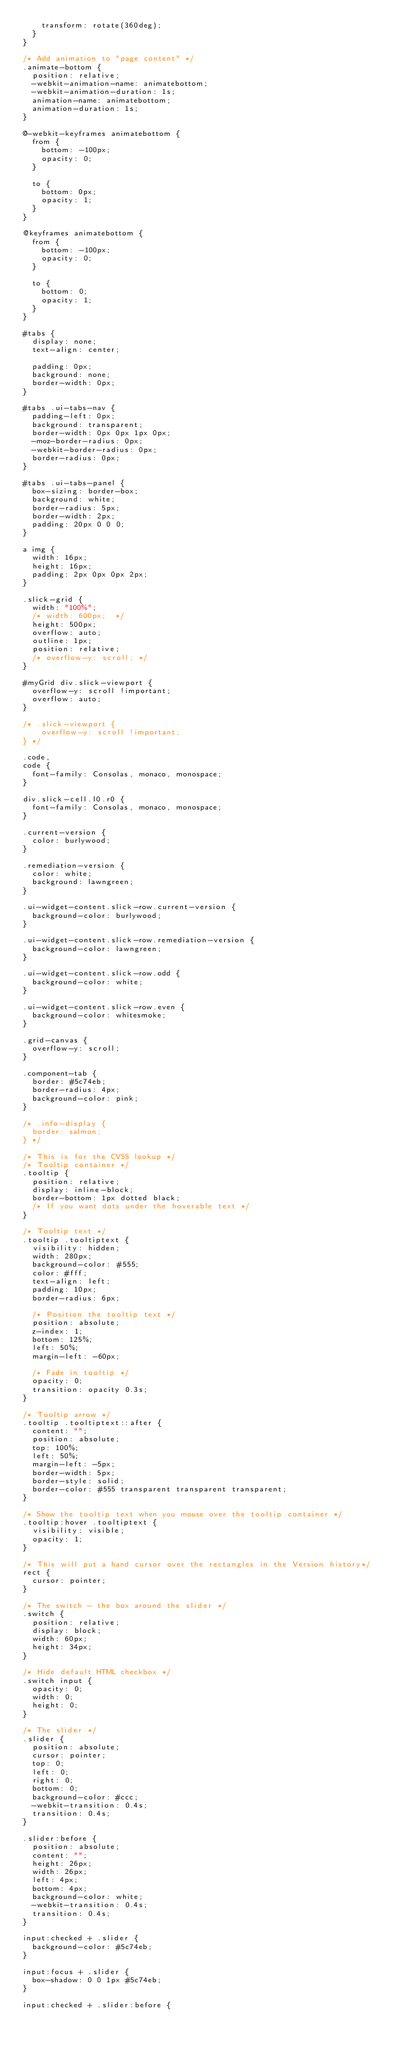<code> <loc_0><loc_0><loc_500><loc_500><_CSS_>    transform: rotate(360deg);
  }
}

/* Add animation to "page content" */
.animate-bottom {
  position: relative;
  -webkit-animation-name: animatebottom;
  -webkit-animation-duration: 1s;
  animation-name: animatebottom;
  animation-duration: 1s;
}

@-webkit-keyframes animatebottom {
  from {
    bottom: -100px;
    opacity: 0;
  }

  to {
    bottom: 0px;
    opacity: 1;
  }
}

@keyframes animatebottom {
  from {
    bottom: -100px;
    opacity: 0;
  }

  to {
    bottom: 0;
    opacity: 1;
  }
}

#tabs {
  display: none;
  text-align: center;

  padding: 0px;
  background: none;
  border-width: 0px;
}

#tabs .ui-tabs-nav {
  padding-left: 0px;
  background: transparent;
  border-width: 0px 0px 1px 0px;
  -moz-border-radius: 0px;
  -webkit-border-radius: 0px;
  border-radius: 0px;
}

#tabs .ui-tabs-panel {
  box-sizing: border-box;
  background: white;
  border-radius: 5px;
  border-width: 2px;
  padding: 20px 0 0 0;
}

a img {
  width: 16px;
  height: 16px;
  padding: 2px 0px 0px 2px;
}

.slick-grid {
  width: "100%";
  /* width: 600px;  */
  height: 500px;
  overflow: auto;
  outline: 1px;
  position: relative;
  /* overflow-y: scroll; */
}

#myGrid div.slick-viewport {
  overflow-y: scroll !important;
  overflow: auto;
}

/* .slick-viewport {
    overflow-y: scroll !important;
} */

.code,
code {
  font-family: Consolas, monaco, monospace;
}

div.slick-cell.l0.r0 {
  font-family: Consolas, monaco, monospace;
}

.current-version {
  color: burlywood;
}

.remediation-version {
  color: white;
  background: lawngreen;
}

.ui-widget-content.slick-row.current-version {
  background-color: burlywood;
}

.ui-widget-content.slick-row.remediation-version {
  background-color: lawngreen;
}

.ui-widget-content.slick-row.odd {
  background-color: white;
}

.ui-widget-content.slick-row.even {
  background-color: whitesmoke;
}

.grid-canvas {
  overflow-y: scroll;
}

.component-tab {
  border: #5c74eb;
  border-radius: 4px;
  background-color: pink;
}

/* .info-display {
  border: salmon;
} */

/* This is for the CVSS lookup */
/* Tooltip container */
.tooltip {
  position: relative;
  display: inline-block;
  border-bottom: 1px dotted black;
  /* If you want dots under the hoverable text */
}

/* Tooltip text */
.tooltip .tooltiptext {
  visibility: hidden;
  width: 280px;
  background-color: #555;
  color: #fff;
  text-align: left;
  padding: 10px;
  border-radius: 6px;

  /* Position the tooltip text */
  position: absolute;
  z-index: 1;
  bottom: 125%;
  left: 50%;
  margin-left: -60px;

  /* Fade in tooltip */
  opacity: 0;
  transition: opacity 0.3s;
}

/* Tooltip arrow */
.tooltip .tooltiptext::after {
  content: "";
  position: absolute;
  top: 100%;
  left: 50%;
  margin-left: -5px;
  border-width: 5px;
  border-style: solid;
  border-color: #555 transparent transparent transparent;
}

/* Show the tooltip text when you mouse over the tooltip container */
.tooltip:hover .tooltiptext {
  visibility: visible;
  opacity: 1;
}

/* This will put a hand cursor over the rectangles in the Version history*/
rect {
  cursor: pointer;
}

/* The switch - the box around the slider */
.switch {
  position: relative;
  display: block;
  width: 60px;
  height: 34px;
}

/* Hide default HTML checkbox */
.switch input {
  opacity: 0;
  width: 0;
  height: 0;
}

/* The slider */
.slider {
  position: absolute;
  cursor: pointer;
  top: 0;
  left: 0;
  right: 0;
  bottom: 0;
  background-color: #ccc;
  -webkit-transition: 0.4s;
  transition: 0.4s;
}

.slider:before {
  position: absolute;
  content: "";
  height: 26px;
  width: 26px;
  left: 4px;
  bottom: 4px;
  background-color: white;
  -webkit-transition: 0.4s;
  transition: 0.4s;
}

input:checked + .slider {
  background-color: #5c74eb;
}

input:focus + .slider {
  box-shadow: 0 0 1px #5c74eb;
}

input:checked + .slider:before {</code> 